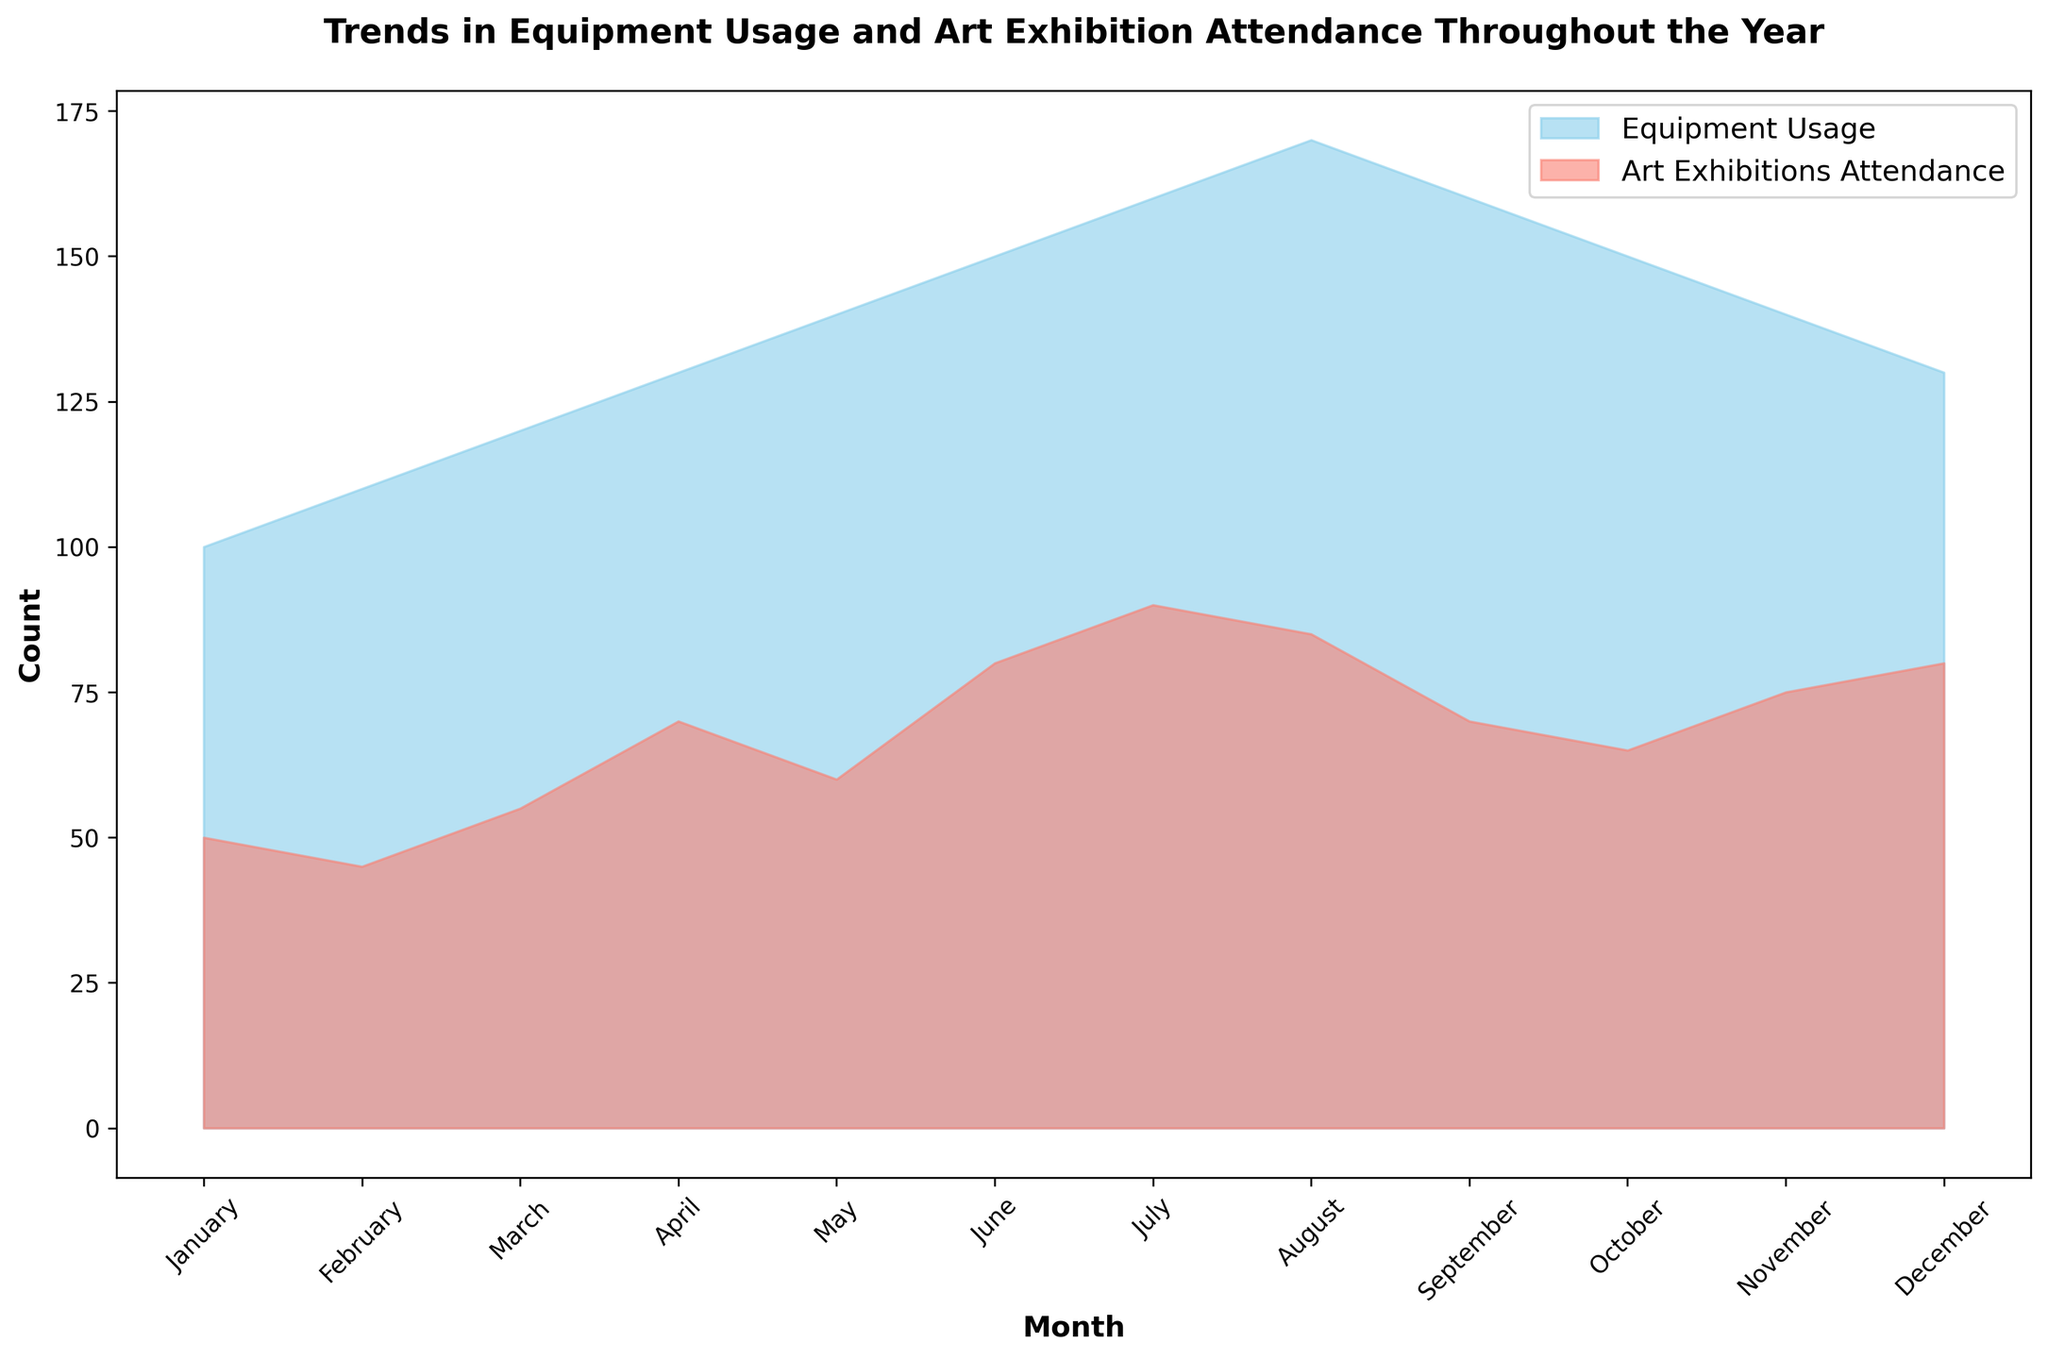Which month has the highest equipment usage? Observe the highest point in the blue area representing Equipment Usage. It is in August.
Answer: August In which month is the attendance for art exhibitions highest? Look for the peak in the salmon-colored area representing Art Exhibitions Attendance. It is in July.
Answer: July Is there any month where Equipment Usage is equal to Art Exhibitions Attendance? Compare the two areas month by month. There is no intersection where they are equal.
Answer: No What is the difference between Equipment Usage and Art Exhibitions Attendance in May? In May, Equipment Usage is 140, and Art Exhibitions Attendance is 60. The difference is 140 - 60.
Answer: 80 Which months show a decline in Equipment Usage compared to the previous month? Check for a decrease in the blue area month by month. The declines occur in September, October, November, and December.
Answer: September, October, November, December Calculate the average Equipment Usage over the first quarter of the year (January to March). Sum the Equipment Usage for January, February, and March (100 + 110 + 120 = 330) and divide by 3.
Answer: 110 Which month has the smallest difference between Equipment Usage and Art Exhibitions Attendance? Calculate the absolute differences for each month, the smallest difference is in June (150 - 80 = 70).
Answer: June How do the trends in Equipment Usage and Art Exhibitions Attendance compare in August? In August, Equipment Usage is 170 while Art Exhibitions Attendance is 85; both are high, with Equipment Usage peaking. Both trends show relative highs in this month, but Equipment Usage is significantly higher.
Answer: Equipment Usage is higher but both are near their peak What is the trend in Art Exhibitions Attendance from June to September? Observe the salmon-colored area from June to September. Art Exhibitions Attendance increases from June to July, slightly decreases in August, and drops more in September.
Answer: Increase, slight decrease, then decrease Is the average Art Exhibitions Attendance greater or lesser than the average Equipment Usage in the second quarter of the year (April to June)? Calculate the averages for April to June. Equipment Usage: (130 + 140 + 150)/3 = 140. Art Exhibitions Attendance: (70 + 60 + 80)/3 = 70.
Answer: Lesser 